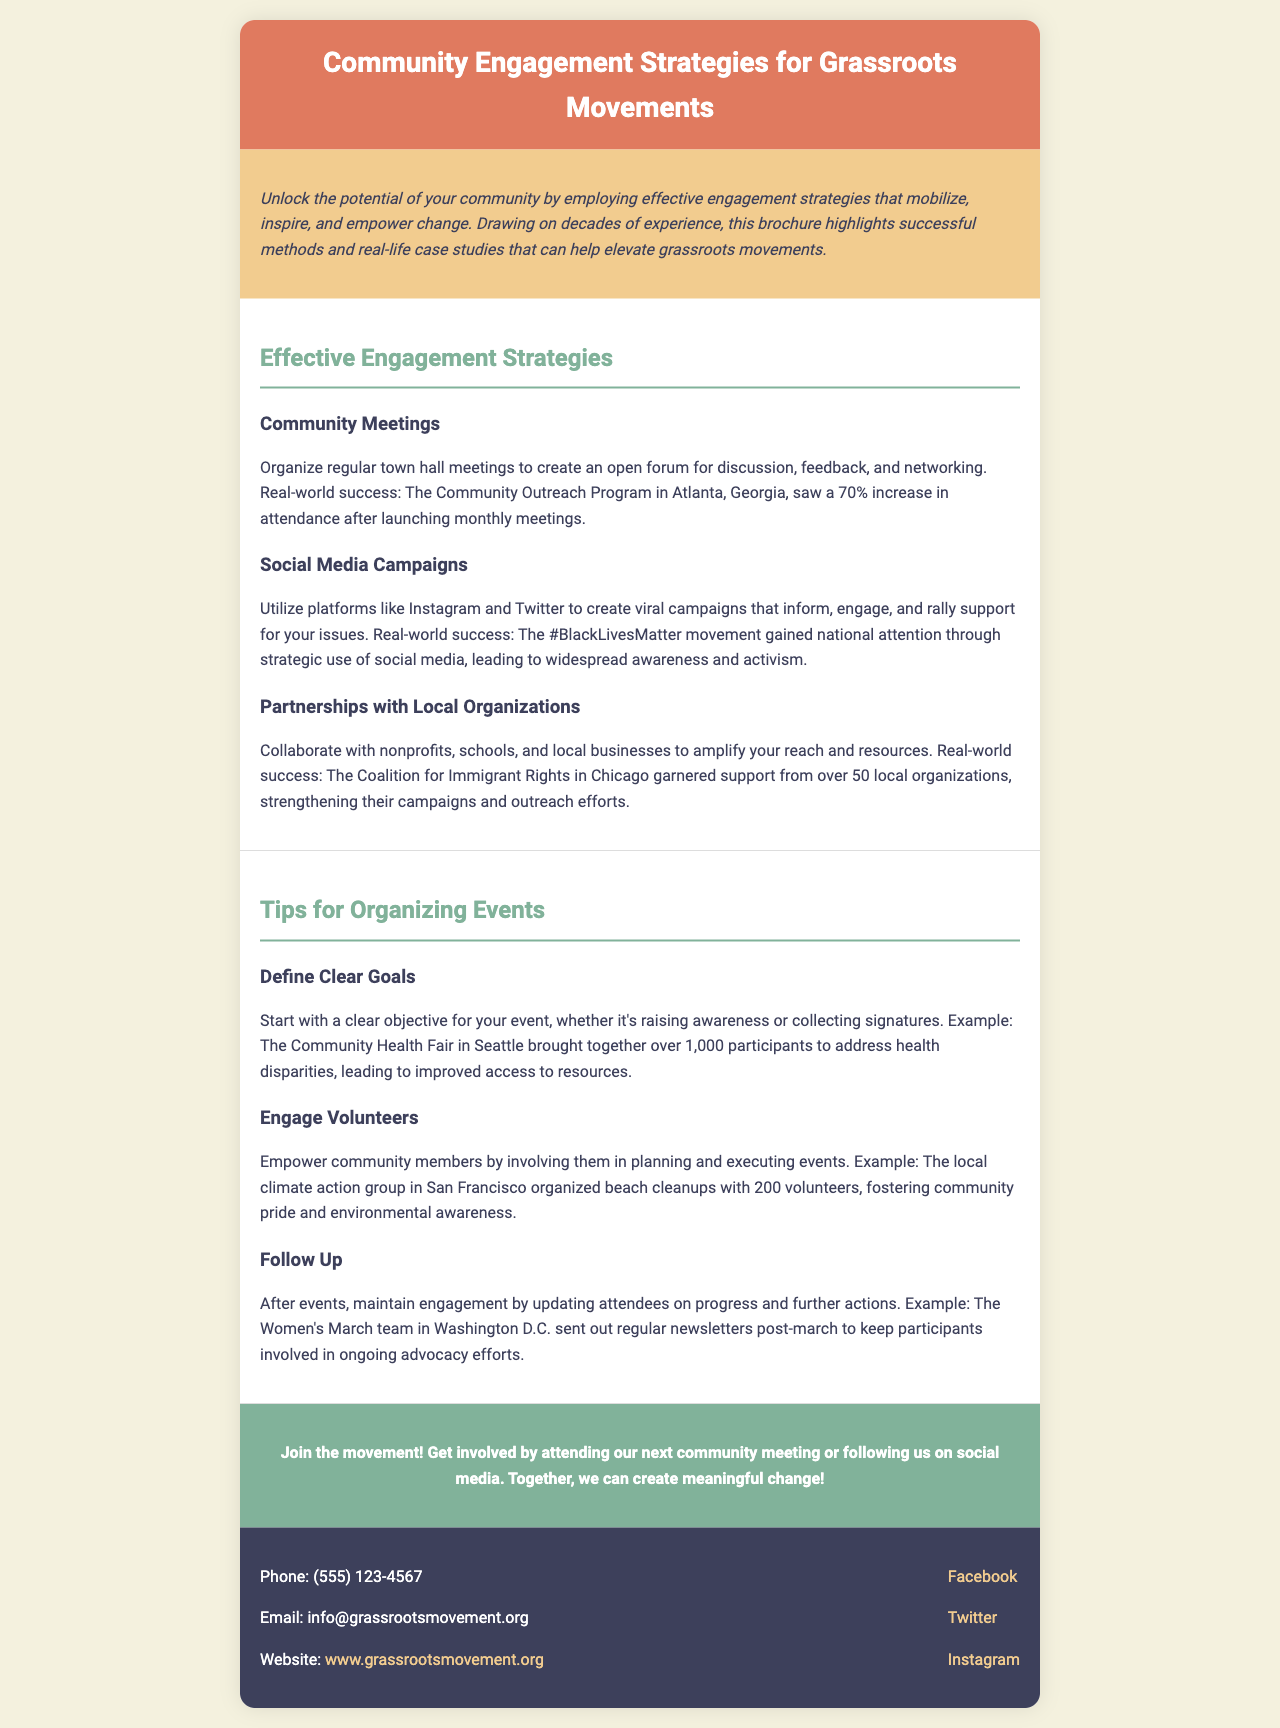What is the title of the brochure? The title is prominently displayed at the top of the brochure.
Answer: Community Engagement Strategies for Grassroots Movements How many local organizations supported the Coalition for Immigrant Rights in Chicago? The text mentions the number of local organizations involved in the Coalition's efforts.
Answer: 50 What is one method suggested for effective engagement? This information is readily available in the section that lists engagement strategies.
Answer: Community Meetings What was the participation rate increase for the Community Outreach Program in Atlanta? The document provides specific statistics regarding the success of community meetings.
Answer: 70% What is one tip for organizing events? The brochure outlines several tips for event organization.
Answer: Define Clear Goals What was the objective of the Community Health Fair in Seattle? The brochure explains the goals for specific events it discusses.
Answer: Address health disparities What social media platform was mentioned for creating viral campaigns? The document specifies a platform used effectively for campaigns.
Answer: Instagram What type of follow-up did the Women's March team in Washington D.C. use? The text explains how the team maintained engagement post-event.
Answer: Regular newsletters 